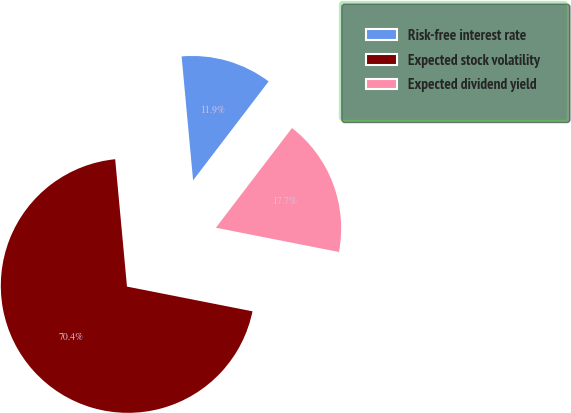<chart> <loc_0><loc_0><loc_500><loc_500><pie_chart><fcel>Risk-free interest rate<fcel>Expected stock volatility<fcel>Expected dividend yield<nl><fcel>11.85%<fcel>70.43%<fcel>17.72%<nl></chart> 